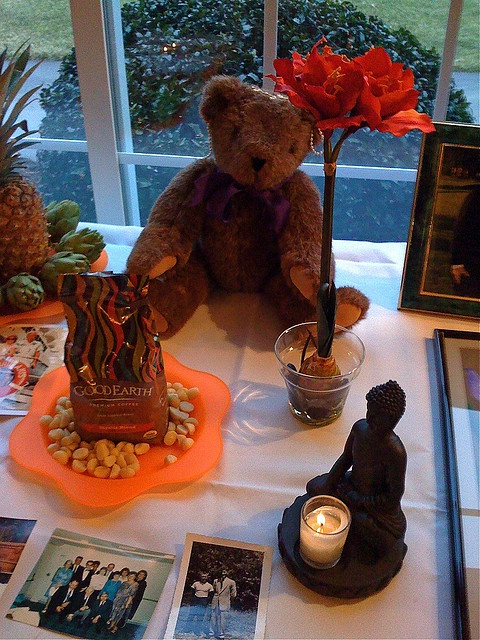Describe the objects in this image and their specific colors. I can see dining table in darkgray, black, maroon, and red tones, teddy bear in darkgray, black, maroon, gray, and brown tones, potted plant in darkgray, maroon, black, and salmon tones, vase in darkgray, maroon, black, and gray tones, and tie in darkgray, black, purple, and navy tones in this image. 